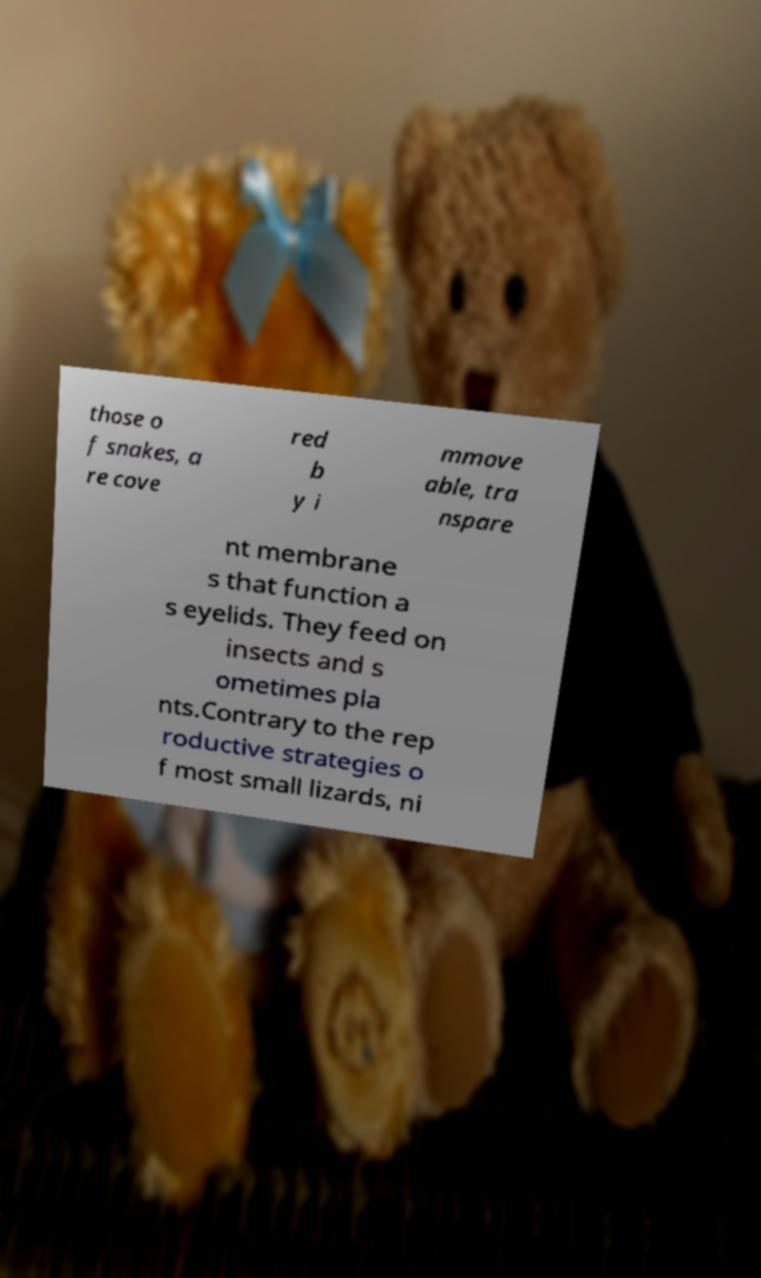Could you assist in decoding the text presented in this image and type it out clearly? those o f snakes, a re cove red b y i mmove able, tra nspare nt membrane s that function a s eyelids. They feed on insects and s ometimes pla nts.Contrary to the rep roductive strategies o f most small lizards, ni 